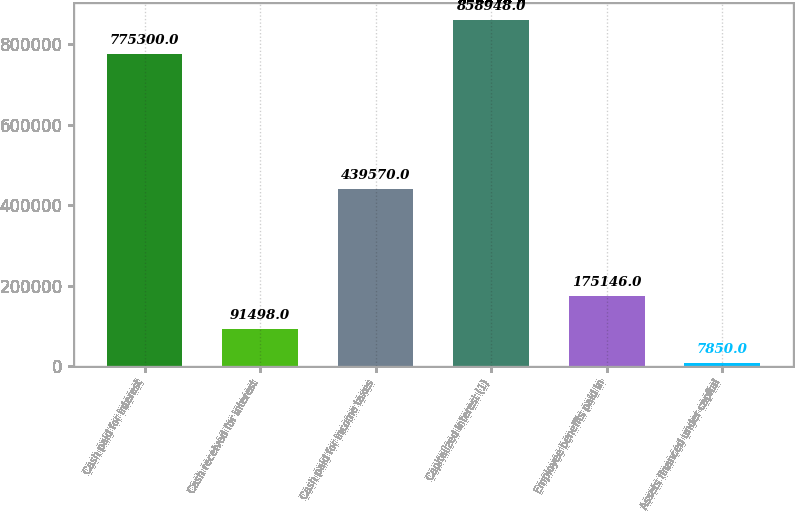<chart> <loc_0><loc_0><loc_500><loc_500><bar_chart><fcel>Cash paid for interest<fcel>Cash received for interest<fcel>Cash paid for income taxes<fcel>Capitalized interest (1)<fcel>Employee benefits paid in<fcel>Assets financed under capital<nl><fcel>775300<fcel>91498<fcel>439570<fcel>858948<fcel>175146<fcel>7850<nl></chart> 